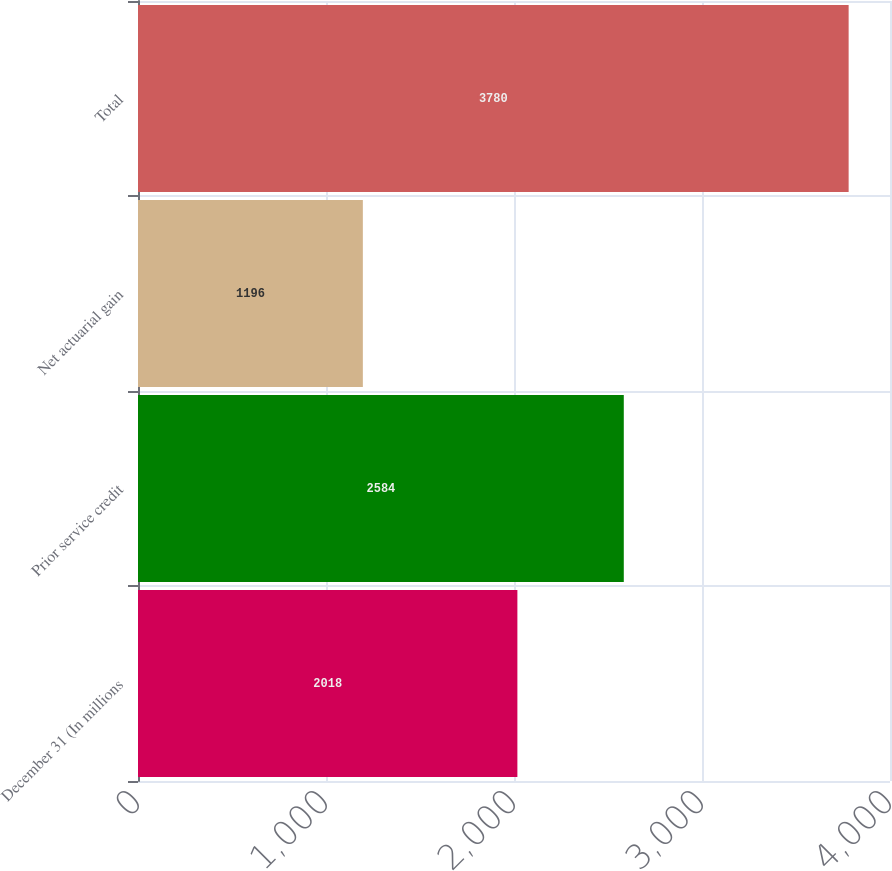Convert chart to OTSL. <chart><loc_0><loc_0><loc_500><loc_500><bar_chart><fcel>December 31 (In millions<fcel>Prior service credit<fcel>Net actuarial gain<fcel>Total<nl><fcel>2018<fcel>2584<fcel>1196<fcel>3780<nl></chart> 